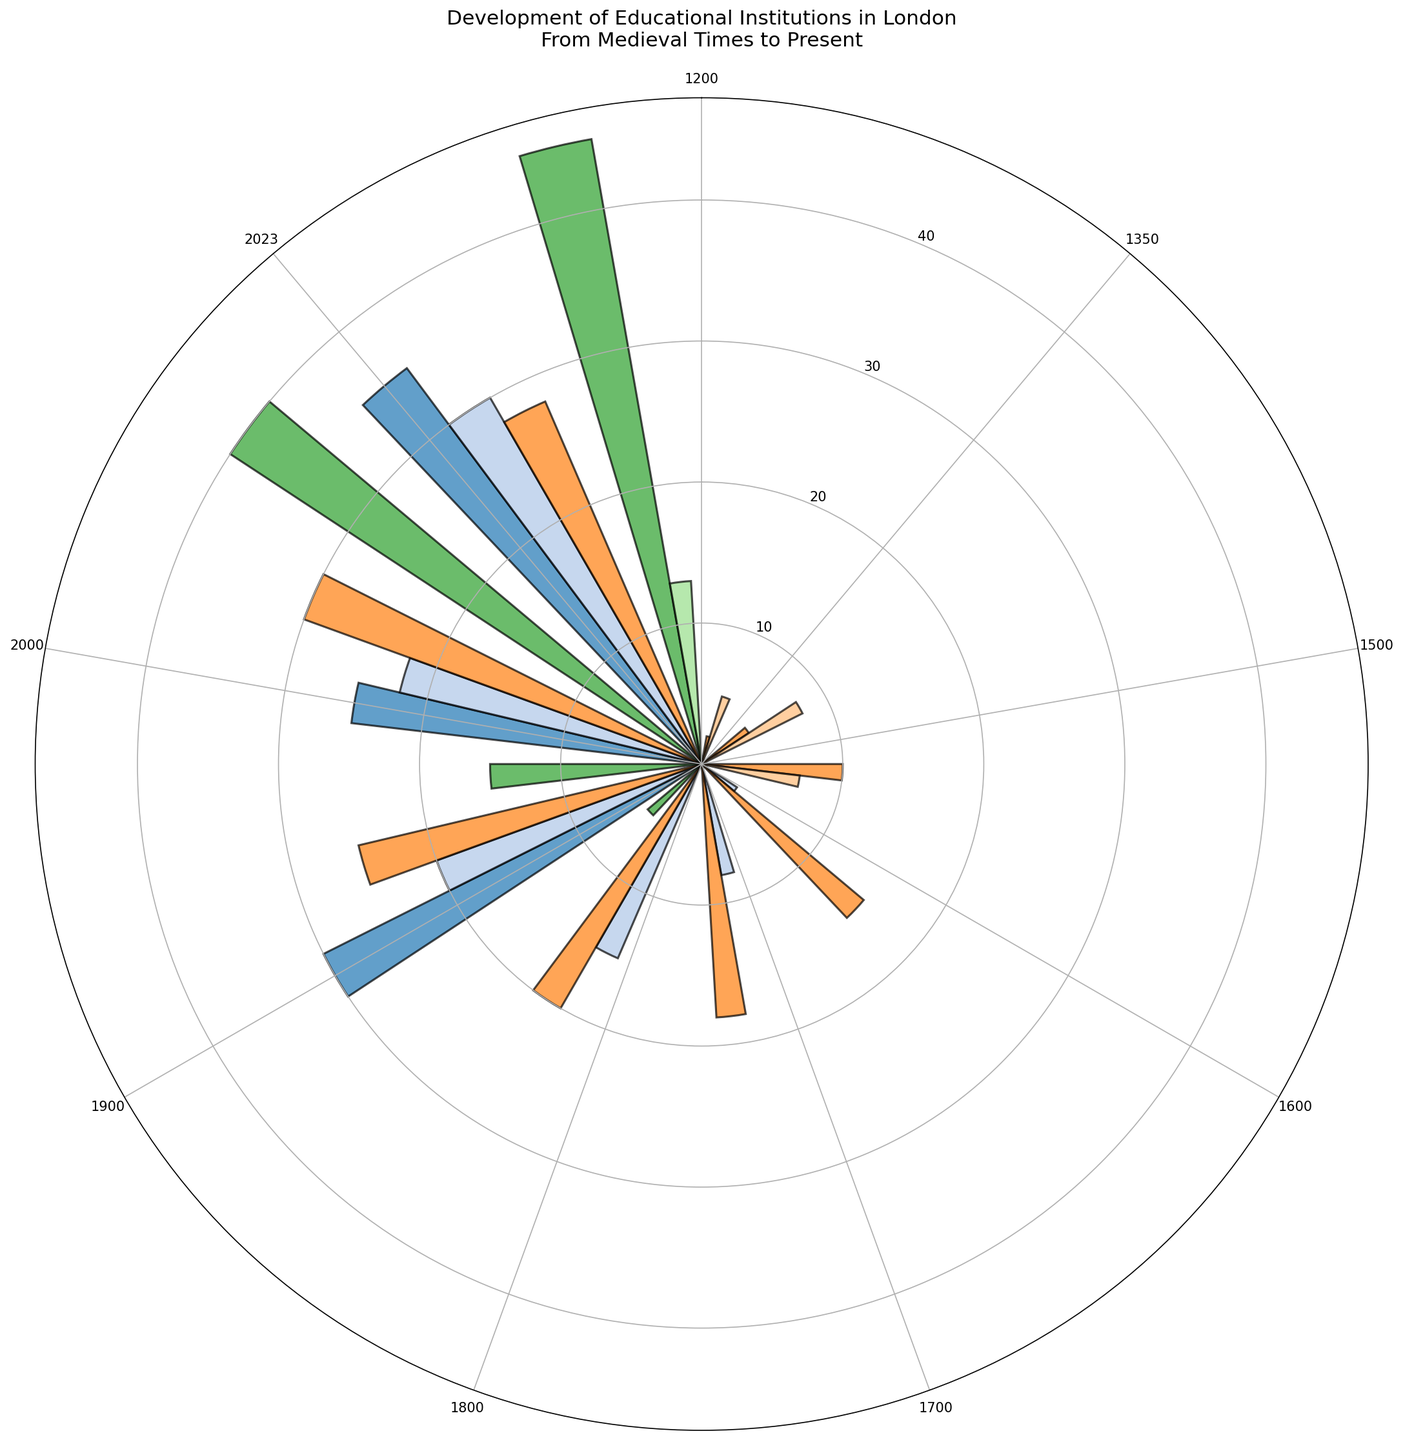How many institutions were present in 2000? To find the total number of institutions in 2000, we sum the numbers for each type of institution listed for that year: Grammar Schools (30), Public Schools (40), Charity Schools (22), Board Schools (25). Total = 30 + 40 + 22 + 25 = 117
Answer: 117 Which year saw the highest number of Public Schools? Among the years listed, 2000 and 2023 both show 40 and 45 Public Schools respectively. So, 2023 has the highest number.
Answer: 2023 Compare the number of Grammar Schools in 1800 and 2000. Which year had more, and by how much? From the chart, Grammar Schools in 1800 are 20 while in 2000, they are 30. The difference is 30 - 20 = 10. Therefore, there were 10 more Grammar Schools in 2000.
Answer: 2000 by 10 What's the difference in the number of institutions between 1900 and 1350? For 1900, sum up the number of each type of institution: Grammar Schools (25), Public Schools (15), Charity Schools (20), Board Schools (30). Total = 25 + 15 + 20 + 30 = 90. For 1350, sum up Monastic Schools (8) and Grammar Schools (4). Total = 8 + 4 = 12. The difference = 90 - 12 = 78
Answer: 78 What is the trend for Charity Schools from 1600 to 2023? By looking at the plot, Charity Schools increased steadily over the years: 3 (1600), 8 (1700), 15 (1800), 20 (1900), 22 (2000), and 30 (2023). So, the trend shows consistent growth.
Answer: Increasing Which year had the highest total number of institutions? Summing the institutions for each year:
- 2023: 28 + 45 + 30 + 35 + 13 = 151
- Other years have lower totals based on visual comparison.
Thus, 2023 had the highest total number of institutions.
Answer: 2023 What are the visual characteristics that differentiate Monastic Schools and Public Schools in the plot? Monastic Schools are shown with fewer but significantly taller bars in earlier years, primarily in 1200, 1350, and 1500, while Public Schools have a more widespread presence in latter years (1800 onwards). The colors for Monastic Schools tend to be consistent while Public Schools’ colors indicate a later spread.
Answer: Monastic Schools: early years, tall bars, consistent colors; Public Schools: later years, widespread, varied colors How many types of institutions appeared for the first time in the 1900s and 2000s respectively? In 1900, Board Schools made their first appearance. In 2000, no new types were introduced. Thus, there was 1 new type in the 1900s and 0 in the 2000s.
Answer: 1 in 1900s, 0 in 2000s 